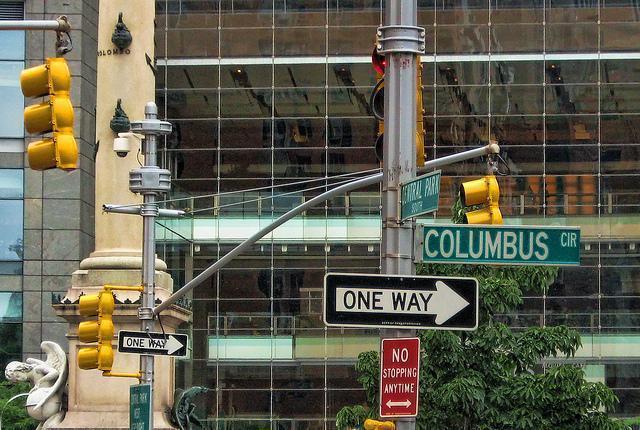Who are the street signs for?
Make your selection from the four choices given to correctly answer the question.
Options: Drivers, directions, downtown, pedestrians. Drivers. 